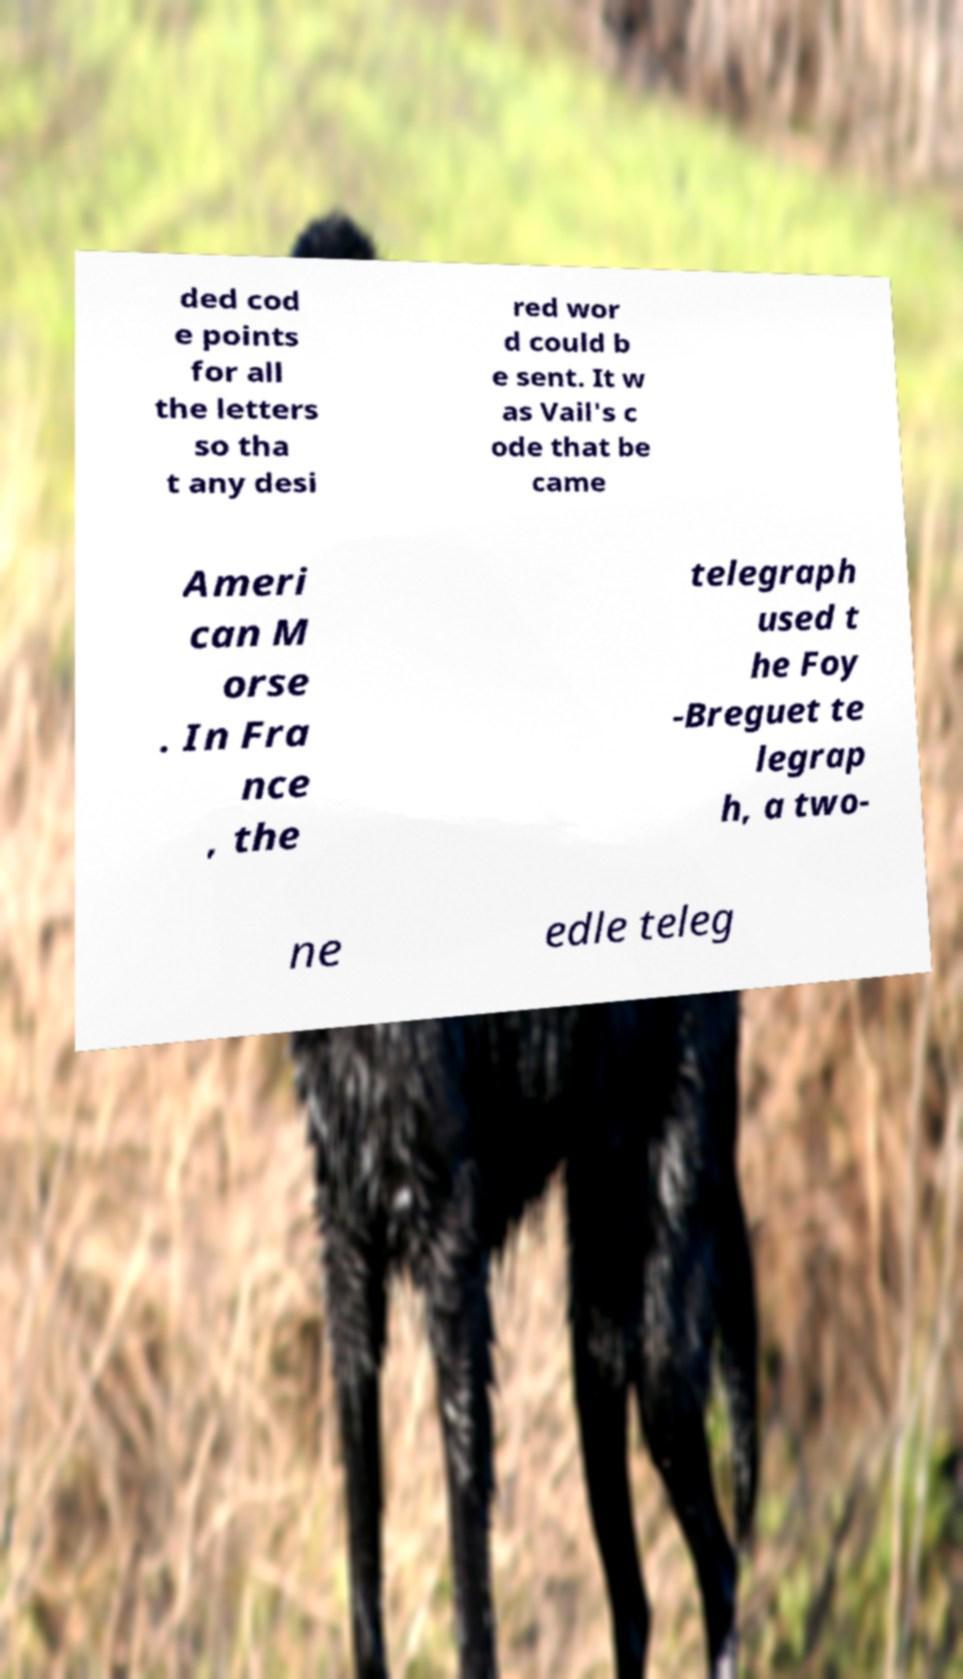Can you read and provide the text displayed in the image?This photo seems to have some interesting text. Can you extract and type it out for me? ded cod e points for all the letters so tha t any desi red wor d could b e sent. It w as Vail's c ode that be came Ameri can M orse . In Fra nce , the telegraph used t he Foy -Breguet te legrap h, a two- ne edle teleg 